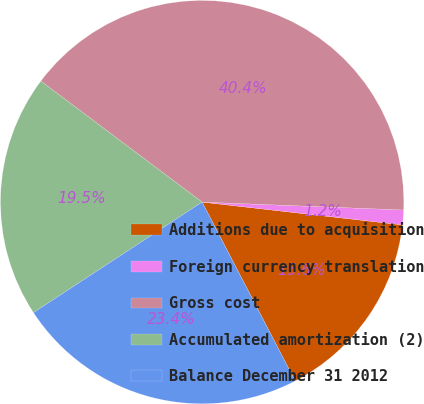Convert chart. <chart><loc_0><loc_0><loc_500><loc_500><pie_chart><fcel>Additions due to acquisition<fcel>Foreign currency translation<fcel>Gross cost<fcel>Accumulated amortization (2)<fcel>Balance December 31 2012<nl><fcel>15.56%<fcel>1.18%<fcel>40.38%<fcel>19.48%<fcel>23.4%<nl></chart> 